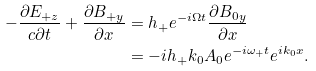<formula> <loc_0><loc_0><loc_500><loc_500>- \frac { \partial E _ { + z } } { c \partial { t } } + \frac { \partial B _ { + y } } { \partial x } & = h _ { + } e ^ { - i \Omega t } \frac { \partial B _ { 0 y } } { \partial x } \\ & = - i h _ { + } k _ { 0 } A _ { 0 } e ^ { - i \omega _ { + } t } e ^ { i k _ { 0 } x } .</formula> 